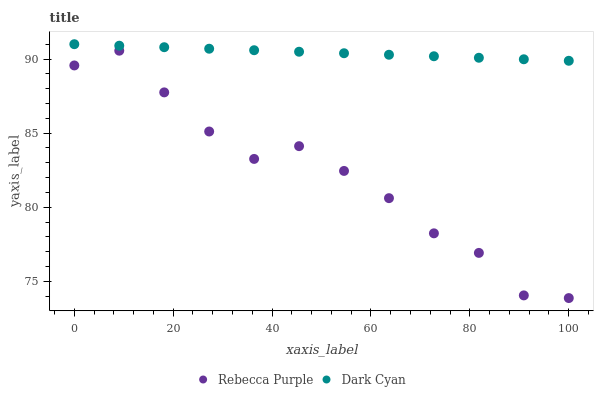Does Rebecca Purple have the minimum area under the curve?
Answer yes or no. Yes. Does Dark Cyan have the maximum area under the curve?
Answer yes or no. Yes. Does Rebecca Purple have the maximum area under the curve?
Answer yes or no. No. Is Dark Cyan the smoothest?
Answer yes or no. Yes. Is Rebecca Purple the roughest?
Answer yes or no. Yes. Is Rebecca Purple the smoothest?
Answer yes or no. No. Does Rebecca Purple have the lowest value?
Answer yes or no. Yes. Does Dark Cyan have the highest value?
Answer yes or no. Yes. Does Rebecca Purple have the highest value?
Answer yes or no. No. Is Rebecca Purple less than Dark Cyan?
Answer yes or no. Yes. Is Dark Cyan greater than Rebecca Purple?
Answer yes or no. Yes. Does Rebecca Purple intersect Dark Cyan?
Answer yes or no. No. 